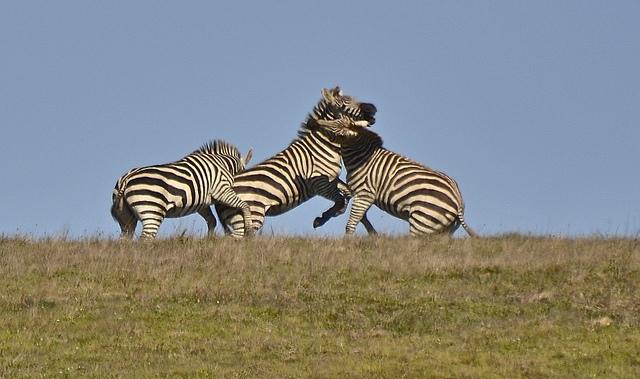Are the zebras facing the same direction?
Be succinct. No. What are these zebras doing?
Write a very short answer. Fighting. Are the zebras playing?
Answer briefly. Yes. What are the zebra doing?
Give a very brief answer. Fighting. How many zebra are standing on their hind legs?
Be succinct. 3. Are zebras peaceful animals?
Concise answer only. Yes. 